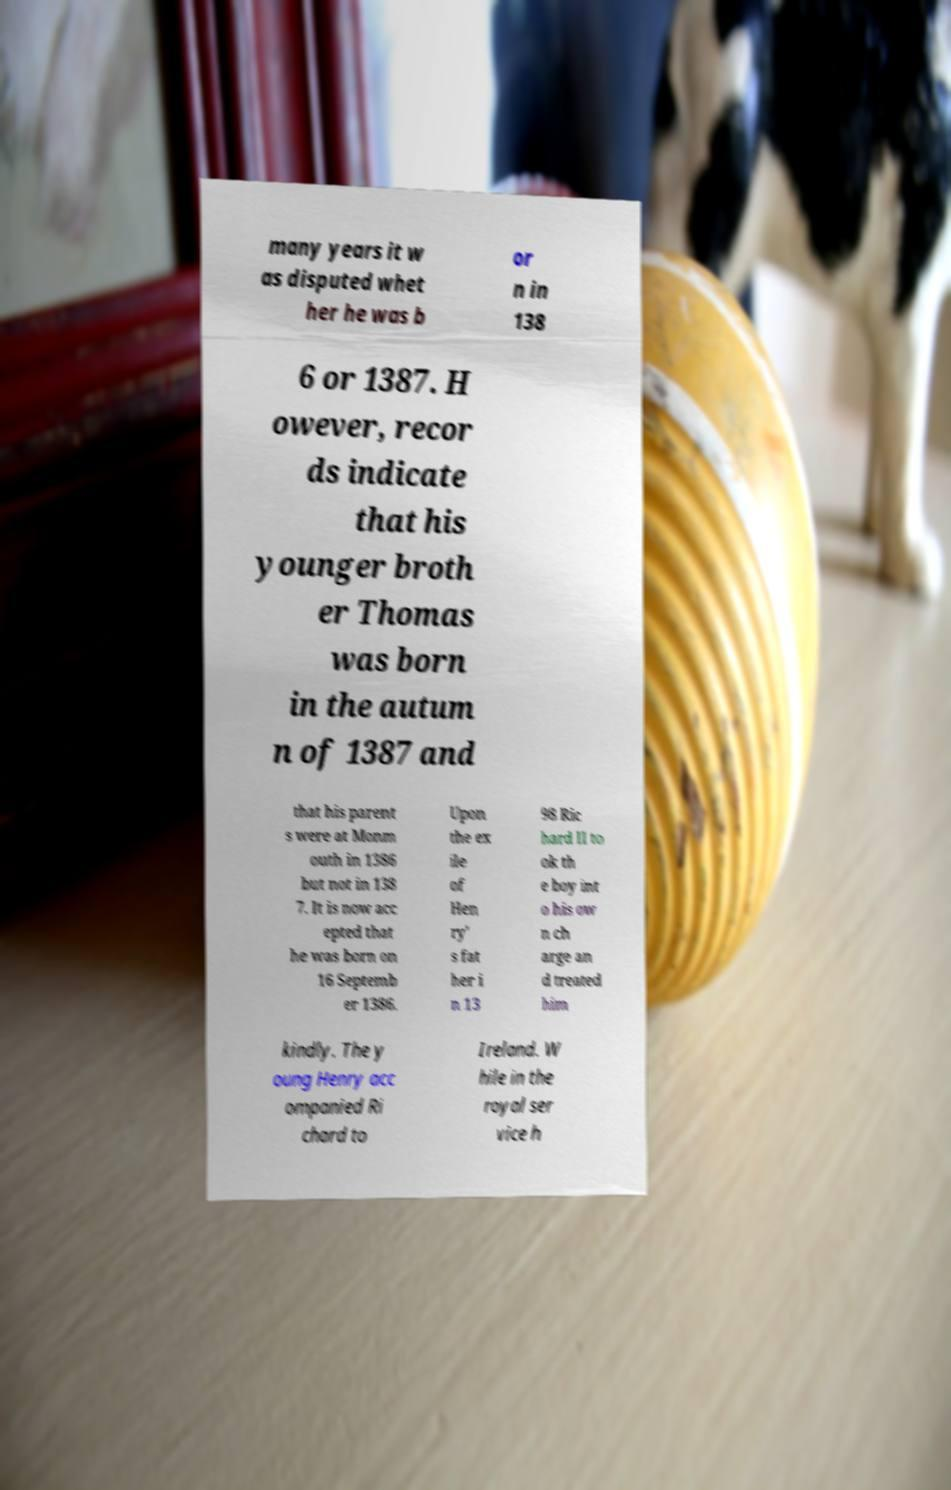Please identify and transcribe the text found in this image. many years it w as disputed whet her he was b or n in 138 6 or 1387. H owever, recor ds indicate that his younger broth er Thomas was born in the autum n of 1387 and that his parent s were at Monm outh in 1386 but not in 138 7. It is now acc epted that he was born on 16 Septemb er 1386. Upon the ex ile of Hen ry' s fat her i n 13 98 Ric hard II to ok th e boy int o his ow n ch arge an d treated him kindly. The y oung Henry acc ompanied Ri chard to Ireland. W hile in the royal ser vice h 